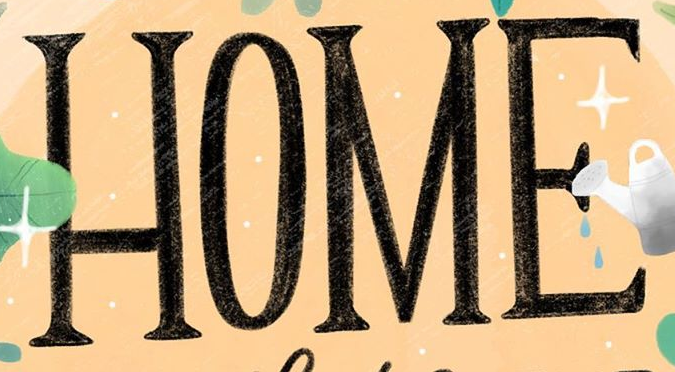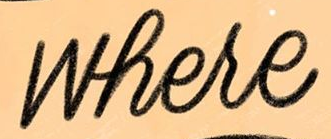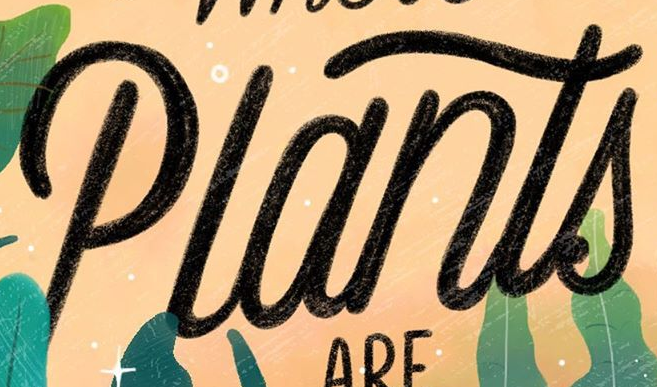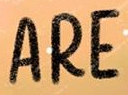Read the text from these images in sequence, separated by a semicolon. HOME; where; Plants; ARE 